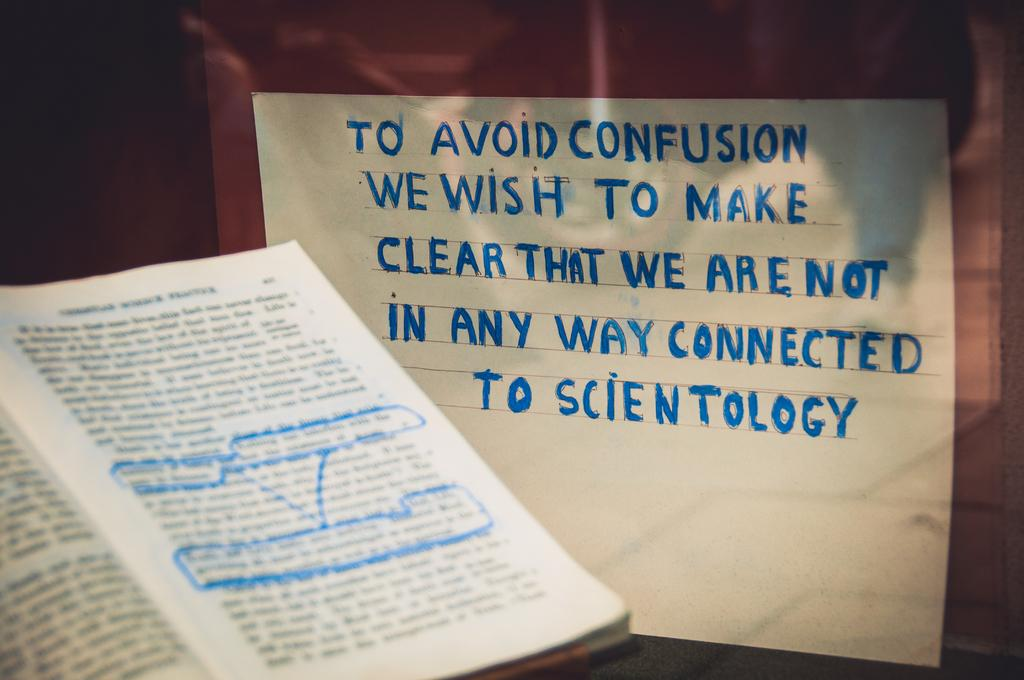<image>
Render a clear and concise summary of the photo. The person who wrote the note is very clear that they do not want to be connected to Scientology. 